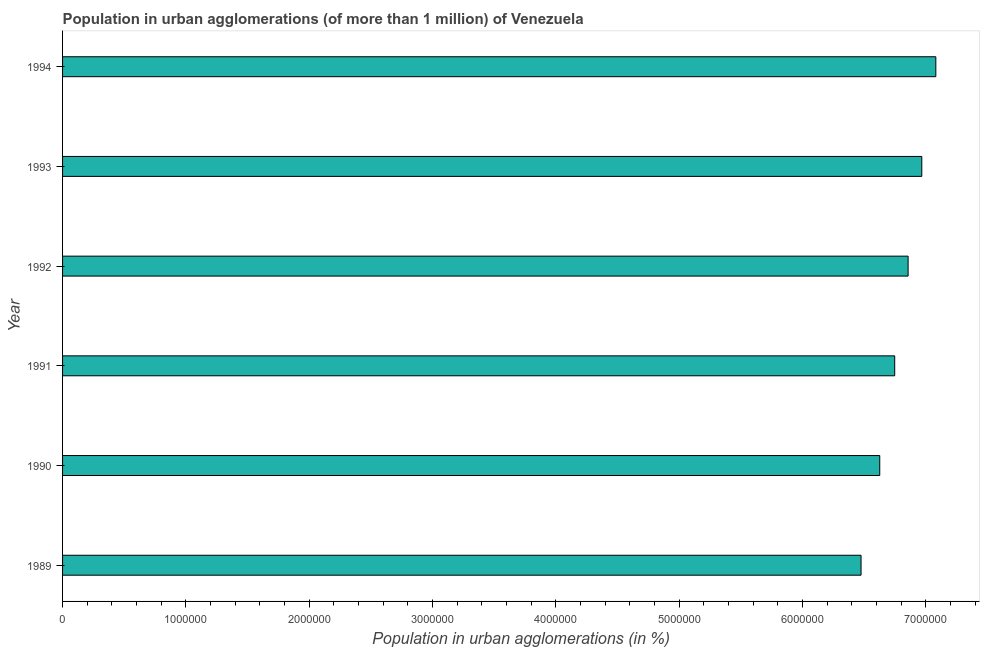Does the graph contain any zero values?
Provide a succinct answer. No. Does the graph contain grids?
Give a very brief answer. No. What is the title of the graph?
Make the answer very short. Population in urban agglomerations (of more than 1 million) of Venezuela. What is the label or title of the X-axis?
Make the answer very short. Population in urban agglomerations (in %). What is the label or title of the Y-axis?
Give a very brief answer. Year. What is the population in urban agglomerations in 1989?
Your answer should be very brief. 6.47e+06. Across all years, what is the maximum population in urban agglomerations?
Offer a terse response. 7.08e+06. Across all years, what is the minimum population in urban agglomerations?
Provide a succinct answer. 6.47e+06. What is the sum of the population in urban agglomerations?
Keep it short and to the point. 4.08e+07. What is the difference between the population in urban agglomerations in 1990 and 1994?
Give a very brief answer. -4.55e+05. What is the average population in urban agglomerations per year?
Offer a very short reply. 6.79e+06. What is the median population in urban agglomerations?
Provide a succinct answer. 6.80e+06. In how many years, is the population in urban agglomerations greater than 4000000 %?
Your answer should be compact. 6. What is the ratio of the population in urban agglomerations in 1989 to that in 1993?
Ensure brevity in your answer.  0.93. Is the difference between the population in urban agglomerations in 1992 and 1993 greater than the difference between any two years?
Provide a short and direct response. No. What is the difference between the highest and the second highest population in urban agglomerations?
Your response must be concise. 1.14e+05. Is the sum of the population in urban agglomerations in 1993 and 1994 greater than the maximum population in urban agglomerations across all years?
Ensure brevity in your answer.  Yes. What is the difference between the highest and the lowest population in urban agglomerations?
Give a very brief answer. 6.06e+05. In how many years, is the population in urban agglomerations greater than the average population in urban agglomerations taken over all years?
Make the answer very short. 3. How many bars are there?
Make the answer very short. 6. How many years are there in the graph?
Make the answer very short. 6. What is the Population in urban agglomerations (in %) in 1989?
Give a very brief answer. 6.47e+06. What is the Population in urban agglomerations (in %) of 1990?
Offer a terse response. 6.63e+06. What is the Population in urban agglomerations (in %) of 1991?
Your answer should be compact. 6.75e+06. What is the Population in urban agglomerations (in %) of 1992?
Ensure brevity in your answer.  6.86e+06. What is the Population in urban agglomerations (in %) of 1993?
Offer a terse response. 6.97e+06. What is the Population in urban agglomerations (in %) in 1994?
Keep it short and to the point. 7.08e+06. What is the difference between the Population in urban agglomerations (in %) in 1989 and 1990?
Your answer should be compact. -1.52e+05. What is the difference between the Population in urban agglomerations (in %) in 1989 and 1991?
Keep it short and to the point. -2.73e+05. What is the difference between the Population in urban agglomerations (in %) in 1989 and 1992?
Provide a short and direct response. -3.82e+05. What is the difference between the Population in urban agglomerations (in %) in 1989 and 1993?
Your response must be concise. -4.93e+05. What is the difference between the Population in urban agglomerations (in %) in 1989 and 1994?
Your answer should be compact. -6.06e+05. What is the difference between the Population in urban agglomerations (in %) in 1990 and 1991?
Provide a succinct answer. -1.21e+05. What is the difference between the Population in urban agglomerations (in %) in 1990 and 1992?
Ensure brevity in your answer.  -2.30e+05. What is the difference between the Population in urban agglomerations (in %) in 1990 and 1993?
Keep it short and to the point. -3.41e+05. What is the difference between the Population in urban agglomerations (in %) in 1990 and 1994?
Give a very brief answer. -4.55e+05. What is the difference between the Population in urban agglomerations (in %) in 1991 and 1992?
Offer a terse response. -1.09e+05. What is the difference between the Population in urban agglomerations (in %) in 1991 and 1993?
Your response must be concise. -2.20e+05. What is the difference between the Population in urban agglomerations (in %) in 1991 and 1994?
Your answer should be compact. -3.33e+05. What is the difference between the Population in urban agglomerations (in %) in 1992 and 1993?
Provide a succinct answer. -1.11e+05. What is the difference between the Population in urban agglomerations (in %) in 1992 and 1994?
Your response must be concise. -2.25e+05. What is the difference between the Population in urban agglomerations (in %) in 1993 and 1994?
Offer a terse response. -1.14e+05. What is the ratio of the Population in urban agglomerations (in %) in 1989 to that in 1992?
Ensure brevity in your answer.  0.94. What is the ratio of the Population in urban agglomerations (in %) in 1989 to that in 1993?
Give a very brief answer. 0.93. What is the ratio of the Population in urban agglomerations (in %) in 1989 to that in 1994?
Ensure brevity in your answer.  0.91. What is the ratio of the Population in urban agglomerations (in %) in 1990 to that in 1992?
Give a very brief answer. 0.97. What is the ratio of the Population in urban agglomerations (in %) in 1990 to that in 1993?
Offer a very short reply. 0.95. What is the ratio of the Population in urban agglomerations (in %) in 1990 to that in 1994?
Provide a short and direct response. 0.94. What is the ratio of the Population in urban agglomerations (in %) in 1991 to that in 1993?
Provide a short and direct response. 0.97. What is the ratio of the Population in urban agglomerations (in %) in 1991 to that in 1994?
Provide a short and direct response. 0.95. What is the ratio of the Population in urban agglomerations (in %) in 1992 to that in 1993?
Your answer should be compact. 0.98. 